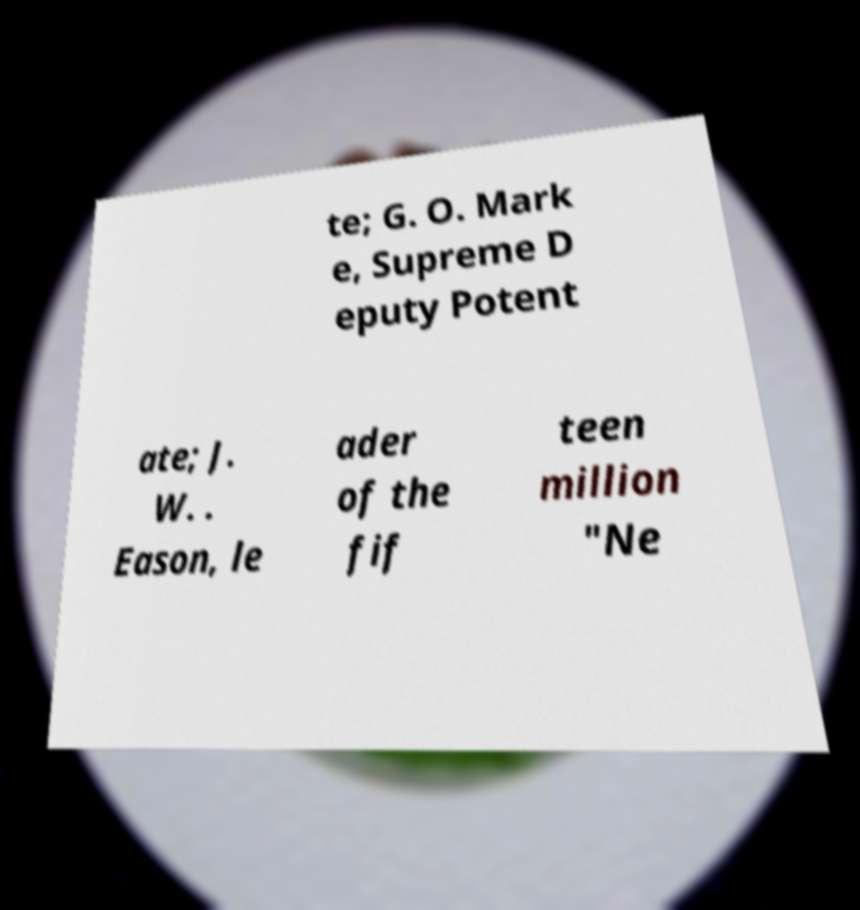Could you assist in decoding the text presented in this image and type it out clearly? te; G. O. Mark e, Supreme D eputy Potent ate; J. W. . Eason, le ader of the fif teen million "Ne 